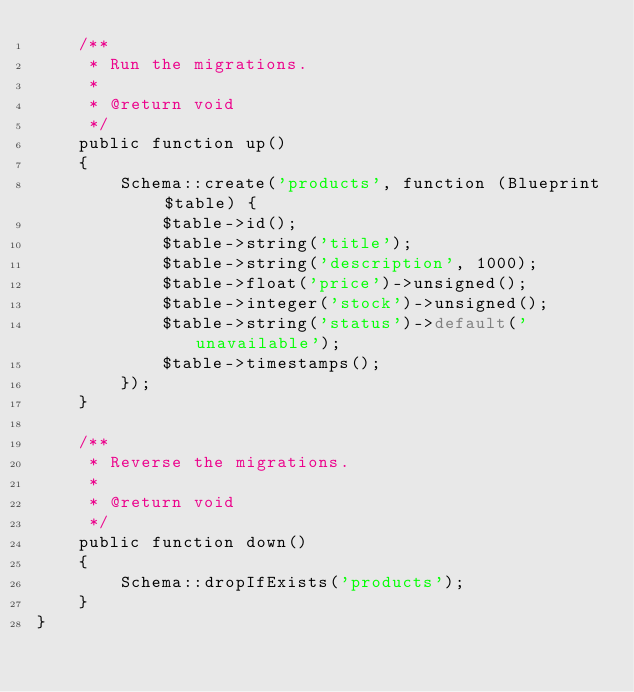Convert code to text. <code><loc_0><loc_0><loc_500><loc_500><_PHP_>    /**
     * Run the migrations.
     *
     * @return void
     */
    public function up()
    {
        Schema::create('products', function (Blueprint $table) {
            $table->id();
            $table->string('title');
            $table->string('description', 1000);
            $table->float('price')->unsigned();
            $table->integer('stock')->unsigned();
            $table->string('status')->default('unavailable');
            $table->timestamps();
        });
    }

    /**
     * Reverse the migrations.
     *
     * @return void
     */
    public function down()
    {
        Schema::dropIfExists('products');
    }
}
</code> 